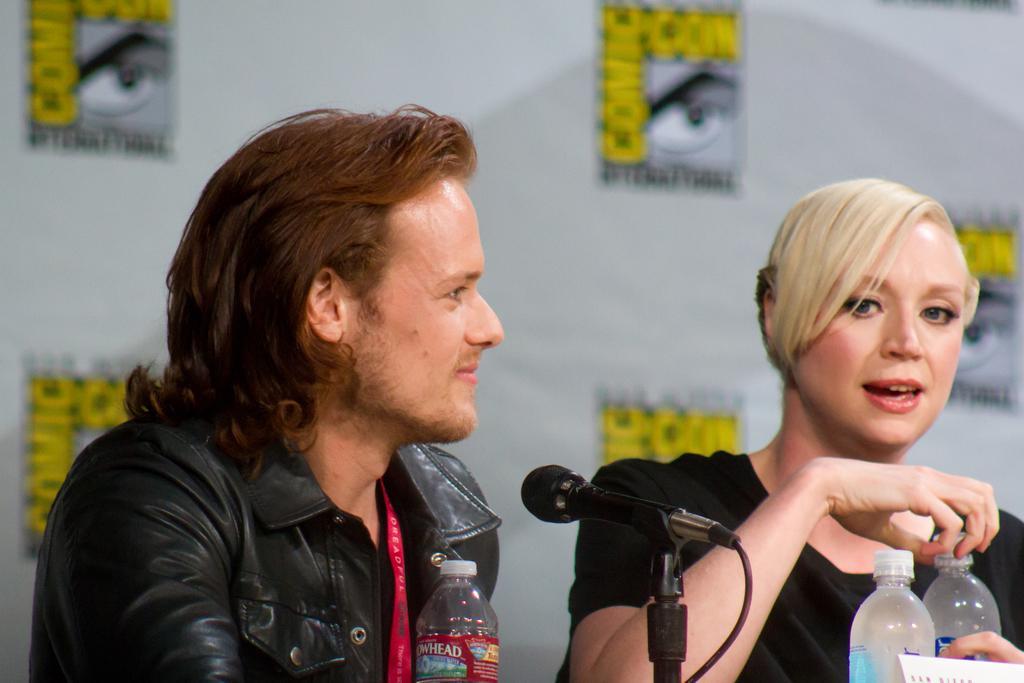Can you describe this image briefly? This is the picture of two people sitting on the chairs and one among them is a man and the other is a woman wearing black shirt sitting on the chair in front of the table on which there are some bottles and behind them there is a poster in yellow, black and white color. 